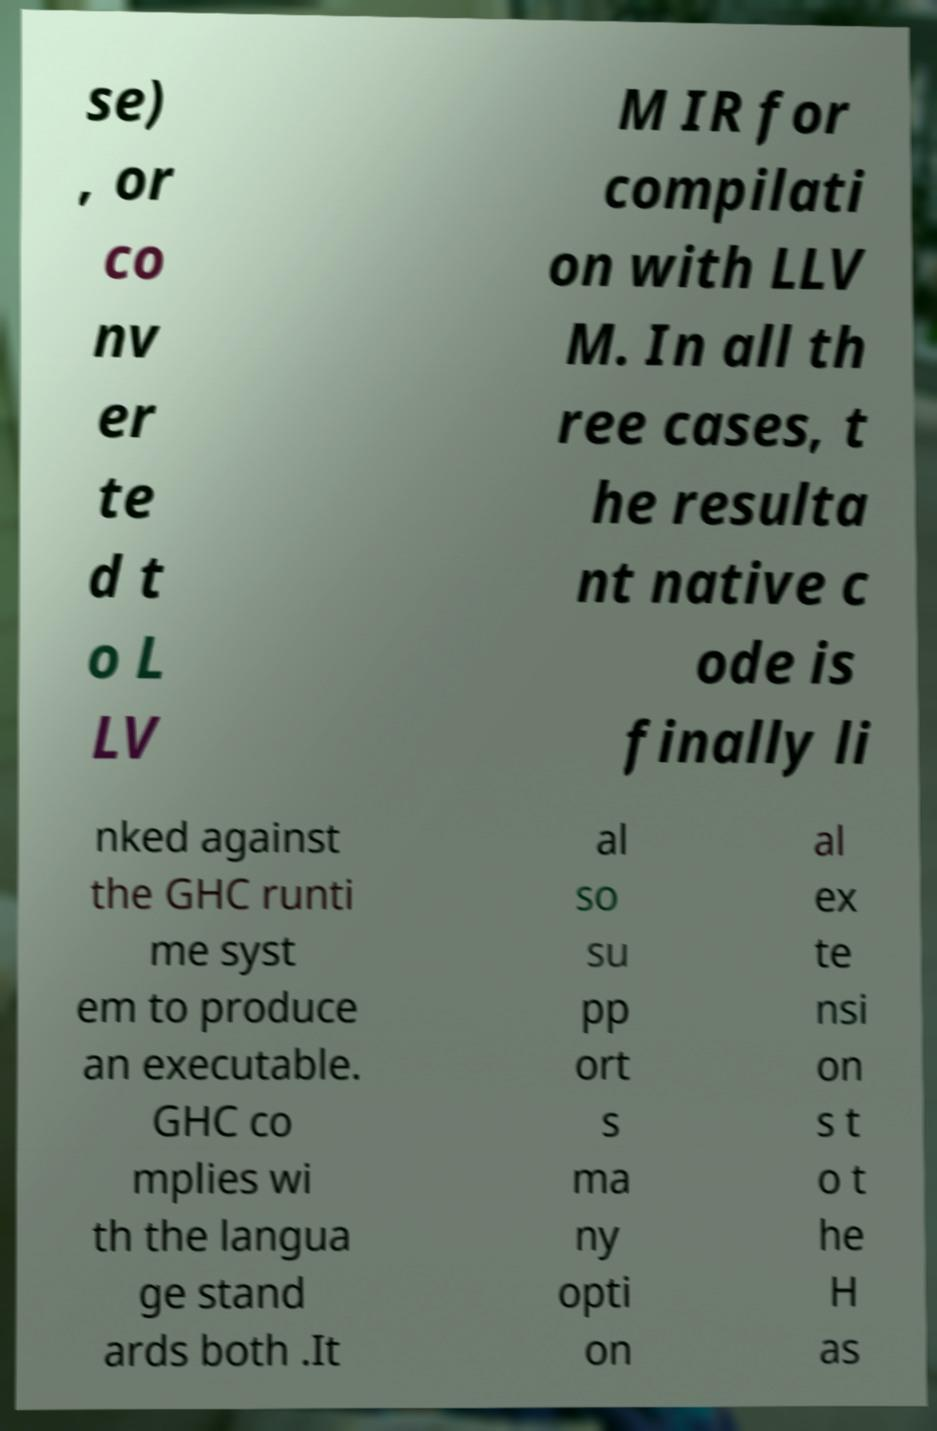For documentation purposes, I need the text within this image transcribed. Could you provide that? se) , or co nv er te d t o L LV M IR for compilati on with LLV M. In all th ree cases, t he resulta nt native c ode is finally li nked against the GHC runti me syst em to produce an executable. GHC co mplies wi th the langua ge stand ards both .It al so su pp ort s ma ny opti on al ex te nsi on s t o t he H as 